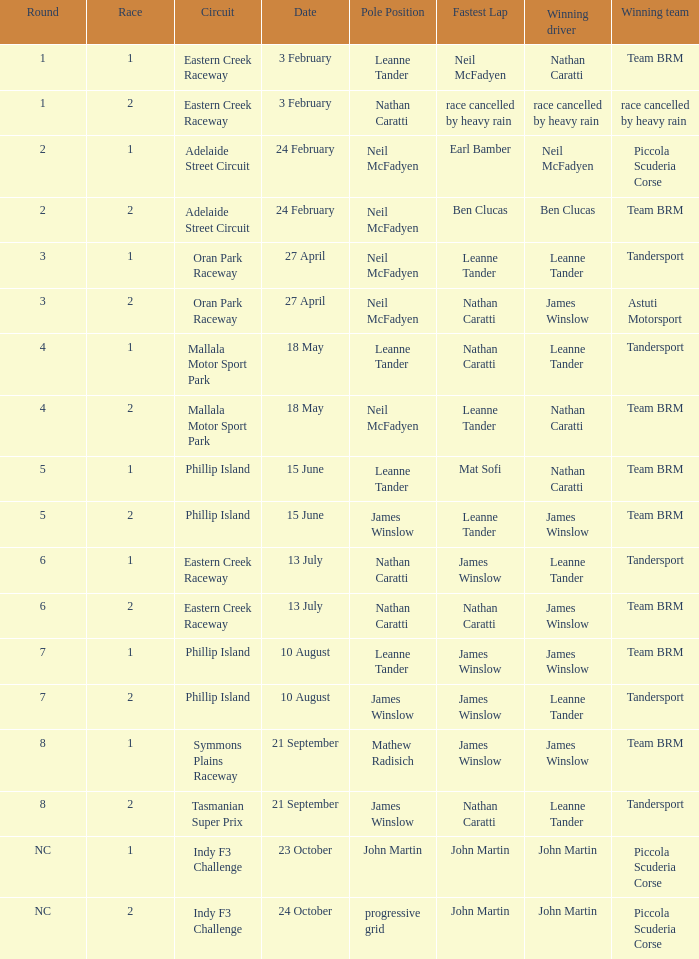Which race number in the Indy F3 Challenge circuit had John Martin in pole position? 1.0. Could you parse the entire table? {'header': ['Round', 'Race', 'Circuit', 'Date', 'Pole Position', 'Fastest Lap', 'Winning driver', 'Winning team'], 'rows': [['1', '1', 'Eastern Creek Raceway', '3 February', 'Leanne Tander', 'Neil McFadyen', 'Nathan Caratti', 'Team BRM'], ['1', '2', 'Eastern Creek Raceway', '3 February', 'Nathan Caratti', 'race cancelled by heavy rain', 'race cancelled by heavy rain', 'race cancelled by heavy rain'], ['2', '1', 'Adelaide Street Circuit', '24 February', 'Neil McFadyen', 'Earl Bamber', 'Neil McFadyen', 'Piccola Scuderia Corse'], ['2', '2', 'Adelaide Street Circuit', '24 February', 'Neil McFadyen', 'Ben Clucas', 'Ben Clucas', 'Team BRM'], ['3', '1', 'Oran Park Raceway', '27 April', 'Neil McFadyen', 'Leanne Tander', 'Leanne Tander', 'Tandersport'], ['3', '2', 'Oran Park Raceway', '27 April', 'Neil McFadyen', 'Nathan Caratti', 'James Winslow', 'Astuti Motorsport'], ['4', '1', 'Mallala Motor Sport Park', '18 May', 'Leanne Tander', 'Nathan Caratti', 'Leanne Tander', 'Tandersport'], ['4', '2', 'Mallala Motor Sport Park', '18 May', 'Neil McFadyen', 'Leanne Tander', 'Nathan Caratti', 'Team BRM'], ['5', '1', 'Phillip Island', '15 June', 'Leanne Tander', 'Mat Sofi', 'Nathan Caratti', 'Team BRM'], ['5', '2', 'Phillip Island', '15 June', 'James Winslow', 'Leanne Tander', 'James Winslow', 'Team BRM'], ['6', '1', 'Eastern Creek Raceway', '13 July', 'Nathan Caratti', 'James Winslow', 'Leanne Tander', 'Tandersport'], ['6', '2', 'Eastern Creek Raceway', '13 July', 'Nathan Caratti', 'Nathan Caratti', 'James Winslow', 'Team BRM'], ['7', '1', 'Phillip Island', '10 August', 'Leanne Tander', 'James Winslow', 'James Winslow', 'Team BRM'], ['7', '2', 'Phillip Island', '10 August', 'James Winslow', 'James Winslow', 'Leanne Tander', 'Tandersport'], ['8', '1', 'Symmons Plains Raceway', '21 September', 'Mathew Radisich', 'James Winslow', 'James Winslow', 'Team BRM'], ['8', '2', 'Tasmanian Super Prix', '21 September', 'James Winslow', 'Nathan Caratti', 'Leanne Tander', 'Tandersport'], ['NC', '1', 'Indy F3 Challenge', '23 October', 'John Martin', 'John Martin', 'John Martin', 'Piccola Scuderia Corse'], ['NC', '2', 'Indy F3 Challenge', '24 October', 'progressive grid', 'John Martin', 'John Martin', 'Piccola Scuderia Corse']]} 